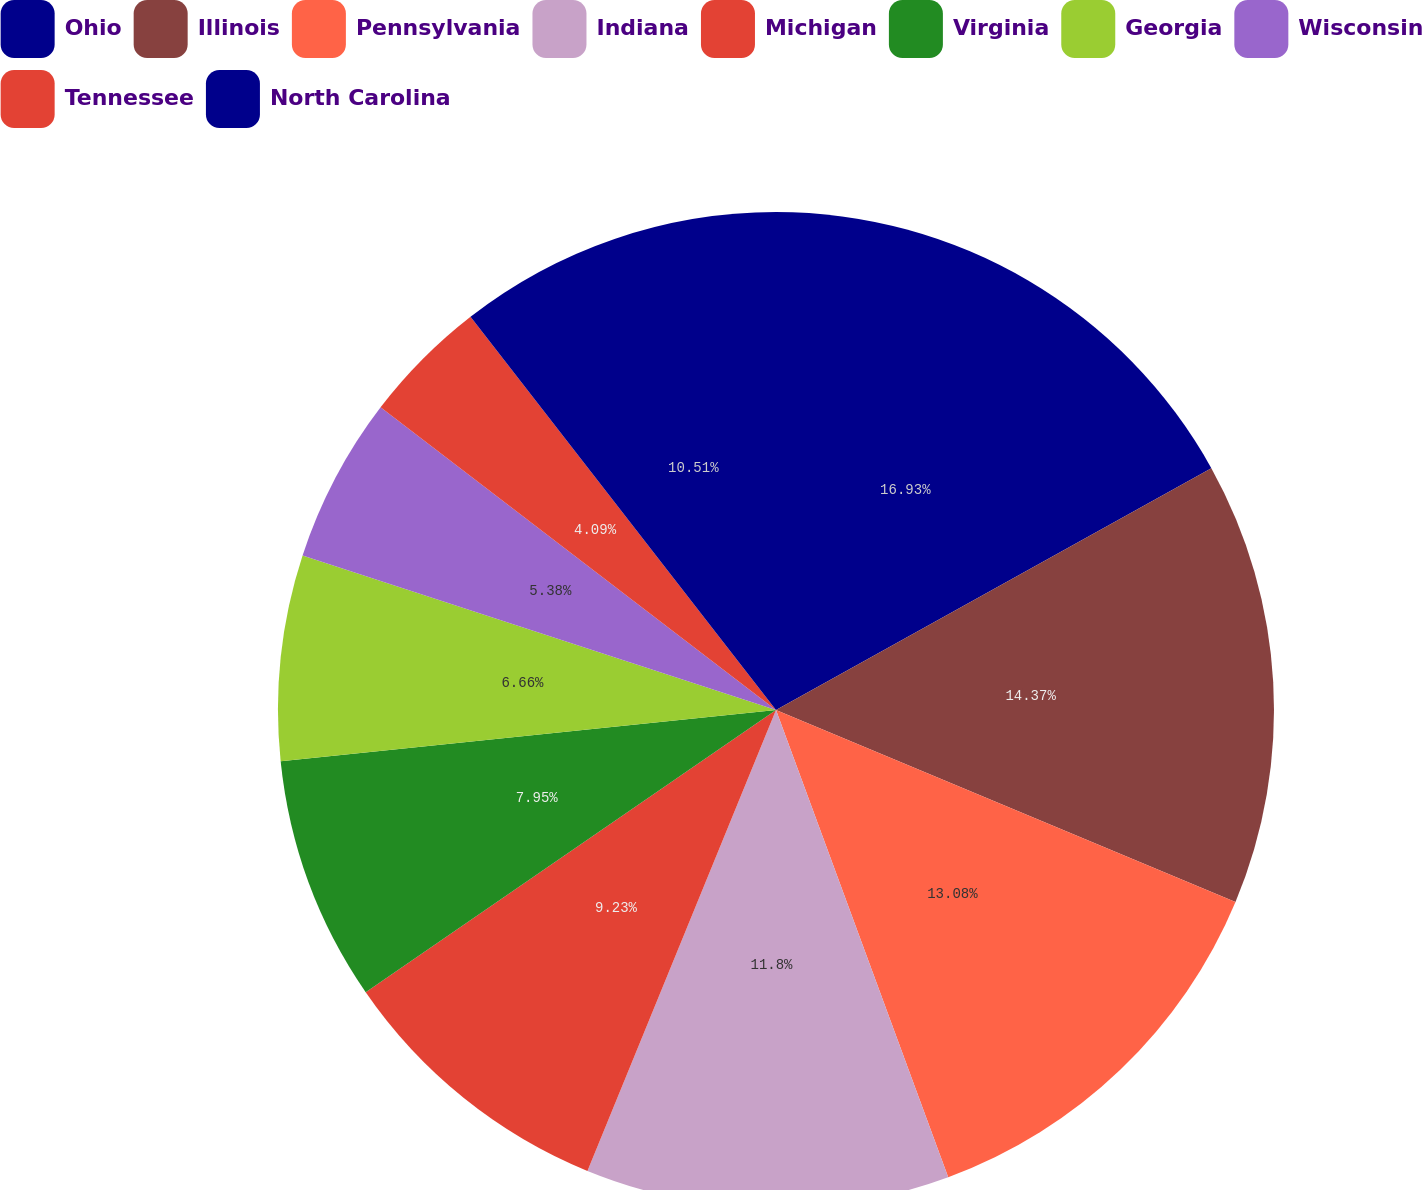<chart> <loc_0><loc_0><loc_500><loc_500><pie_chart><fcel>Ohio<fcel>Illinois<fcel>Pennsylvania<fcel>Indiana<fcel>Michigan<fcel>Virginia<fcel>Georgia<fcel>Wisconsin<fcel>Tennessee<fcel>North Carolina<nl><fcel>16.93%<fcel>14.37%<fcel>13.08%<fcel>11.8%<fcel>9.23%<fcel>7.95%<fcel>6.66%<fcel>5.38%<fcel>4.09%<fcel>10.51%<nl></chart> 